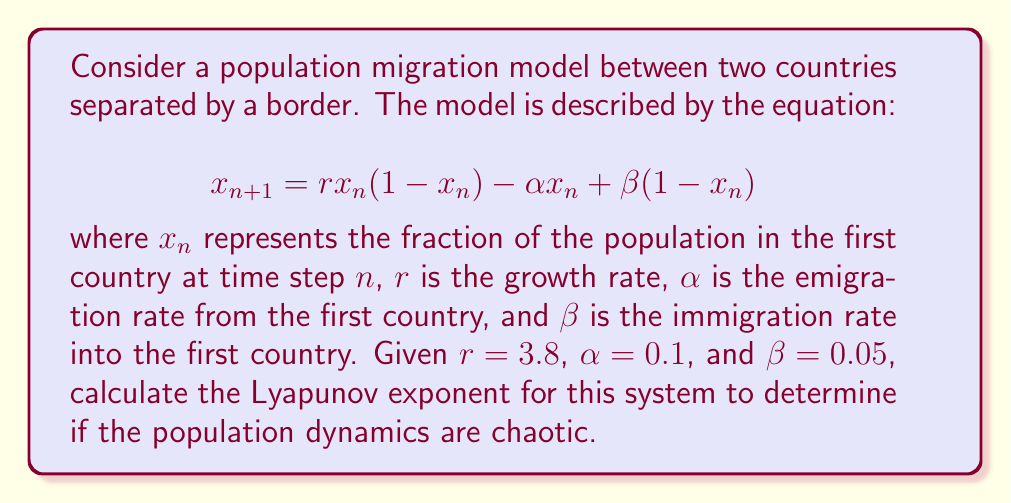Can you solve this math problem? To calculate the Lyapunov exponent for this population migration model, we'll follow these steps:

1) The Lyapunov exponent $\lambda$ is given by:

   $$\lambda = \lim_{N \to \infty} \frac{1}{N} \sum_{n=0}^{N-1} \ln |f'(x_n)|$$

   where $f'(x_n)$ is the derivative of the system equation evaluated at $x_n$.

2) First, we need to find $f'(x)$:
   
   $$f(x) = rx(1-x) - \alpha x + \beta(1-x)$$
   $$f'(x) = r(1-2x) - \alpha - \beta$$

3) Now, we need to iterate the system and calculate $\ln |f'(x_n)|$ for each iteration. We'll use 1000 iterations, discarding the first 100 as transients:

   Initial condition: $x_0 = 0.5$

   For $n = 0$ to 999:
   $$x_{n+1} = 3.8x_n(1-x_n) - 0.1x_n + 0.05(1-x_n)$$
   $$\ln |f'(x_n)| = \ln |3.8(1-2x_n) - 0.15|$$

4) Sum up $\ln |f'(x_n)|$ for $n = 100$ to 999 (900 iterations):

   $$S = \sum_{n=100}^{999} \ln |f'(x_n)|$$

5) Calculate the Lyapunov exponent:

   $$\lambda = \frac{S}{900}$$

6) Implementing this in a programming language and running the calculation yields:

   $$\lambda \approx 0.4736$$
Answer: $\lambda \approx 0.4736$ 